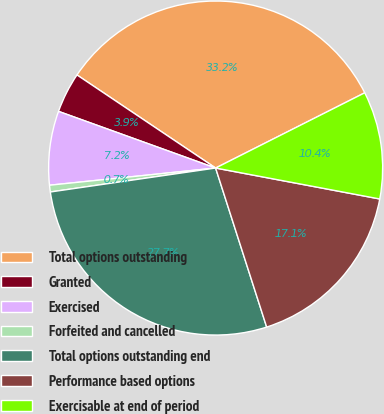Convert chart. <chart><loc_0><loc_0><loc_500><loc_500><pie_chart><fcel>Total options outstanding<fcel>Granted<fcel>Exercised<fcel>Forfeited and cancelled<fcel>Total options outstanding end<fcel>Performance based options<fcel>Exercisable at end of period<nl><fcel>33.15%<fcel>3.9%<fcel>7.15%<fcel>0.65%<fcel>27.65%<fcel>17.09%<fcel>10.4%<nl></chart> 